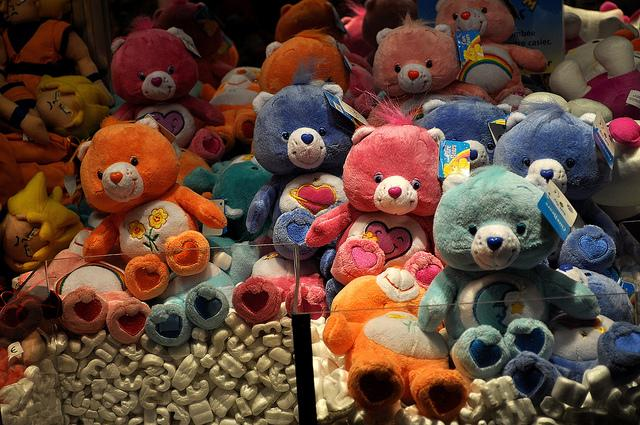What are the small white objects below the stuffed animals? Please explain your reasoning. packing peanuts. These cushion items to protect them 